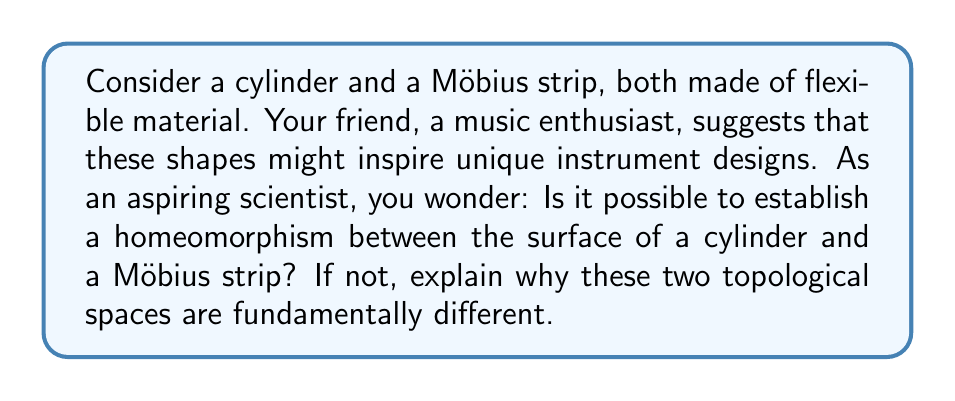Solve this math problem. To determine if two topological spaces are homeomorphic, we need to find a continuous bijective function between them with a continuous inverse. Let's analyze the properties of both surfaces:

1. Cylinder:
   - Two-sided surface
   - Has two distinct boundary components (circles)
   - Orientable
   - Euler characteristic: $\chi = 0$

2. Möbius strip:
   - One-sided surface
   - Has one boundary component
   - Non-orientable
   - Euler characteristic: $\chi = 0$

Despite having the same Euler characteristic, these surfaces differ in fundamental ways:

a) Orientability: The cylinder is orientable, meaning we can consistently define a normal vector field on its surface. The Möbius strip is non-orientable; if we try to define a normal vector field, we encounter inconsistencies when traversing the strip.

b) Number of sides: The cylinder has two distinct sides (inner and outer), while the Möbius strip has only one side. This can be demonstrated by tracing a path along the surface without crossing an edge.

c) Boundary components: The cylinder has two separate boundary circles, whereas the Möbius strip has only one continuous boundary.

These topological invariants cannot be changed by continuous deformations. Therefore, it is impossible to establish a homeomorphism between a cylinder and a Möbius strip.

To visualize this, imagine trying to transform one shape into the other:

[asy]
import geometry;

size(200);

// Cylinder
path p1 = (0,0)..(1,1)..(2,0);
path p2 = (0,3)..(1,2)..(2,3);
draw(p1);
draw(p2);
draw((0,0)--(0,3));
draw((2,0)--(2,3));

// Möbius strip
path p3 = (5,0)..(6,1.5)..(7,0);
draw(p3);
draw((5,0)--(7,3));
draw((7,0)--(5,3));

label("Cylinder", (1,-0.5));
label("Möbius strip", (6,-0.5));
[/asy]

No matter how you deform the cylinder, you cannot create the twist necessary to form a Möbius strip without cutting and reattaching the surface, which would violate the continuity requirement of a homeomorphism.
Answer: No, it is not possible to establish a homeomorphism between the surface of a cylinder and a Möbius strip. They are fundamentally different topological spaces due to their distinct properties in orientability, number of sides, and boundary components. 